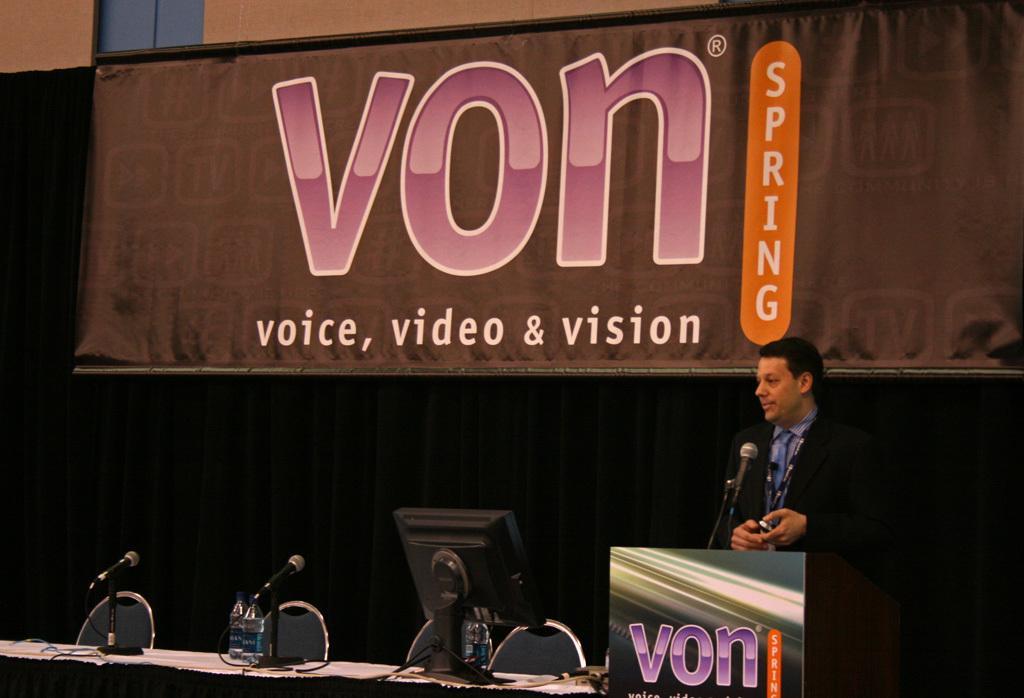How would you summarize this image in a sentence or two? On the left side of the image we can see a man is standing in-front of the podium and talking. On the podium, we can see the text and mic with stand. At the bottom of the image we can see a table. On the table we can see the papers, bottles, screen, mics with stands. In the background of the image we can see the wall, chairs, banner. In the top left corner we can see the window. 